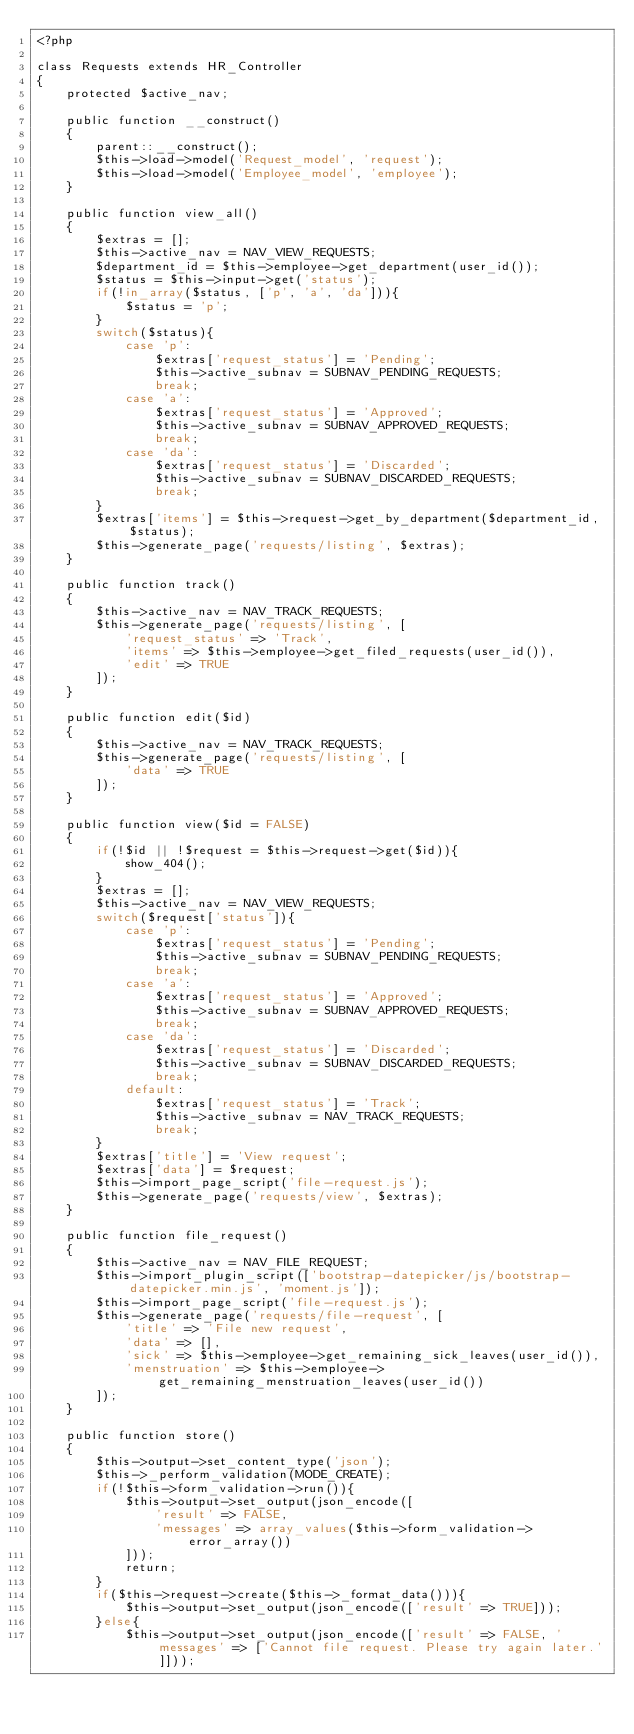Convert code to text. <code><loc_0><loc_0><loc_500><loc_500><_PHP_><?php

class Requests extends HR_Controller
{
	protected $active_nav;

	public function __construct()
	{
		parent::__construct();
		$this->load->model('Request_model', 'request');
		$this->load->model('Employee_model', 'employee');
	}

	public function view_all()
	{
		$extras = [];
		$this->active_nav = NAV_VIEW_REQUESTS;
		$department_id = $this->employee->get_department(user_id());
		$status = $this->input->get('status');
		if(!in_array($status, ['p', 'a', 'da'])){
			$status = 'p';
		}
		switch($status){
			case 'p': 
				$extras['request_status'] = 'Pending';
				$this->active_subnav = SUBNAV_PENDING_REQUESTS;
				break;
			case 'a': 
				$extras['request_status'] = 'Approved';
				$this->active_subnav = SUBNAV_APPROVED_REQUESTS;
				break;
			case 'da': 
				$extras['request_status'] = 'Discarded';
				$this->active_subnav = SUBNAV_DISCARDED_REQUESTS;
				break;
		}
		$extras['items'] = $this->request->get_by_department($department_id, $status);
		$this->generate_page('requests/listing', $extras);
	}

	public function track()
	{
		$this->active_nav = NAV_TRACK_REQUESTS;
		$this->generate_page('requests/listing', [
			'request_status' => 'Track',
			'items' => $this->employee->get_filed_requests(user_id()),
			'edit' => TRUE
		]);
	}

	public function edit($id)
	{
		$this->active_nav = NAV_TRACK_REQUESTS;
		$this->generate_page('requests/listing', [
			'data' => TRUE
		]);
	}

	public function view($id = FALSE)
	{
		if(!$id || !$request = $this->request->get($id)){
			show_404();
		}
		$extras = [];
		$this->active_nav = NAV_VIEW_REQUESTS;
		switch($request['status']){
			case 'p': 
				$extras['request_status'] = 'Pending';
				$this->active_subnav = SUBNAV_PENDING_REQUESTS;
				break;
			case 'a': 
				$extras['request_status'] = 'Approved';
				$this->active_subnav = SUBNAV_APPROVED_REQUESTS;
				break;
			case 'da': 
				$extras['request_status'] = 'Discarded';
				$this->active_subnav = SUBNAV_DISCARDED_REQUESTS;
				break;
			default: 
				$extras['request_status'] = 'Track';
				$this->active_subnav = NAV_TRACK_REQUESTS;
				break;
		}
		$extras['title'] = 'View request';
		$extras['data'] = $request;
		$this->import_page_script('file-request.js');
		$this->generate_page('requests/view', $extras);
	}

	public function file_request()
	{
		$this->active_nav = NAV_FILE_REQUEST;
		$this->import_plugin_script(['bootstrap-datepicker/js/bootstrap-datepicker.min.js', 'moment.js']);
		$this->import_page_script('file-request.js');
		$this->generate_page('requests/file-request', [
			'title' => 'File new request',
			'data' => [],
			'sick' => $this->employee->get_remaining_sick_leaves(user_id()),
			'menstruation' => $this->employee->get_remaining_menstruation_leaves(user_id())
		]);
	}

	public function store()
	{
		$this->output->set_content_type('json');
		$this->_perform_validation(MODE_CREATE);
		if(!$this->form_validation->run()){
			$this->output->set_output(json_encode([
				'result' => FALSE,
				'messages' => array_values($this->form_validation->error_array())
			]));
			return;
		}
		if($this->request->create($this->_format_data())){
			$this->output->set_output(json_encode(['result' => TRUE]));
		}else{
			$this->output->set_output(json_encode(['result' => FALSE, 'messages' => ['Cannot file request. Please try again later.']]));</code> 